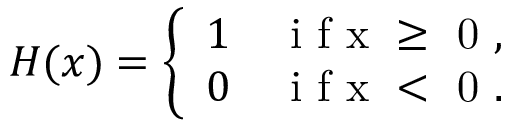<formula> <loc_0><loc_0><loc_500><loc_500>H ( x ) = \left \{ \begin{array} { l l } { 1 } & { i f x \geq 0 , } \\ { 0 } & { i f x < 0 . } \end{array}</formula> 